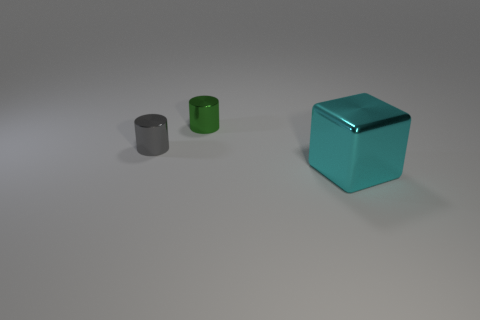Subtract all green cylinders. How many cylinders are left? 1 Add 3 large gray spheres. How many objects exist? 6 Subtract all blocks. How many objects are left? 2 Subtract 1 cylinders. How many cylinders are left? 1 Subtract 1 gray cylinders. How many objects are left? 2 Subtract all purple cubes. Subtract all red balls. How many cubes are left? 1 Subtract all blue blocks. How many green cylinders are left? 1 Subtract all big cyan shiny cubes. Subtract all large purple metal cylinders. How many objects are left? 2 Add 3 small gray shiny things. How many small gray shiny things are left? 4 Add 1 tiny gray shiny things. How many tiny gray shiny things exist? 2 